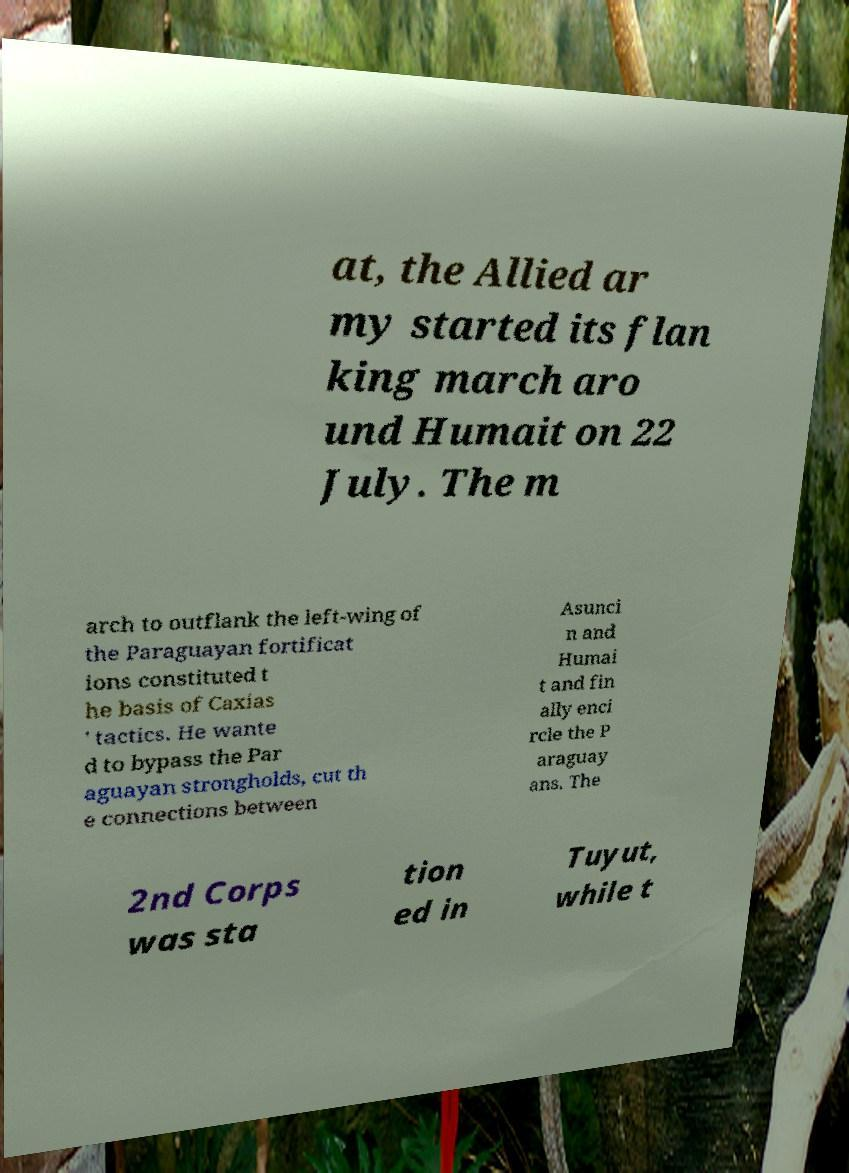Please read and relay the text visible in this image. What does it say? at, the Allied ar my started its flan king march aro und Humait on 22 July. The m arch to outflank the left-wing of the Paraguayan fortificat ions constituted t he basis of Caxias ' tactics. He wante d to bypass the Par aguayan strongholds, cut th e connections between Asunci n and Humai t and fin ally enci rcle the P araguay ans. The 2nd Corps was sta tion ed in Tuyut, while t 